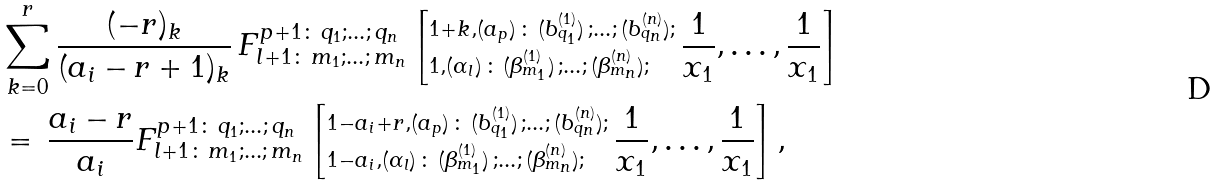<formula> <loc_0><loc_0><loc_500><loc_500>& \sum _ { k = 0 } ^ { r } \frac { ( - r ) _ { k } } { ( a _ { i } - r + 1 ) _ { k } } \, F _ { { l + 1 } \colon \, m _ { 1 } ; \dots ; \, m _ { n } } ^ { p + 1 \colon \, q _ { 1 } ; \dots ; \, q _ { n } } \left [ ^ { 1 + k , ( a _ { p } ) \, \colon \, ( b ^ { ( 1 ) } _ { q _ { 1 } } ) \, ; \dots ; \, ( b ^ { ( n ) } _ { q _ { n } } ) ; } _ { 1 , ( \alpha _ { l } ) \, \colon \, ( \beta ^ { ( 1 ) } _ { m _ { 1 } } ) \, ; \dots ; \, ( \beta ^ { ( n ) } _ { m _ { n } } ) ; } \, \frac { 1 } { x _ { 1 } } , \dots , \frac { 1 } { x _ { 1 } } \right ] \\ & = \, \frac { a _ { i } - r } { a _ { i } } F _ { { l + 1 } \colon \, m _ { 1 } ; \dots ; \, m _ { n } } ^ { p + 1 \colon \, q _ { 1 } ; \dots ; \, q _ { n } } \left [ ^ { 1 - a _ { i } + r , ( a _ { p } ) \, \colon \, ( b ^ { ( 1 ) } _ { q _ { 1 } } ) \, ; \dots ; \, ( b ^ { ( n ) } _ { q _ { n } } ) ; } _ { 1 - a _ { i } , ( \alpha _ { l } ) \, \colon \, ( \beta ^ { ( 1 ) } _ { m _ { 1 } } ) \, ; \dots ; \, ( \beta ^ { ( n ) } _ { m _ { n } } ) ; } \, \frac { 1 } { x _ { 1 } } , \dots , \frac { 1 } { x _ { 1 } } \right ] ,</formula> 